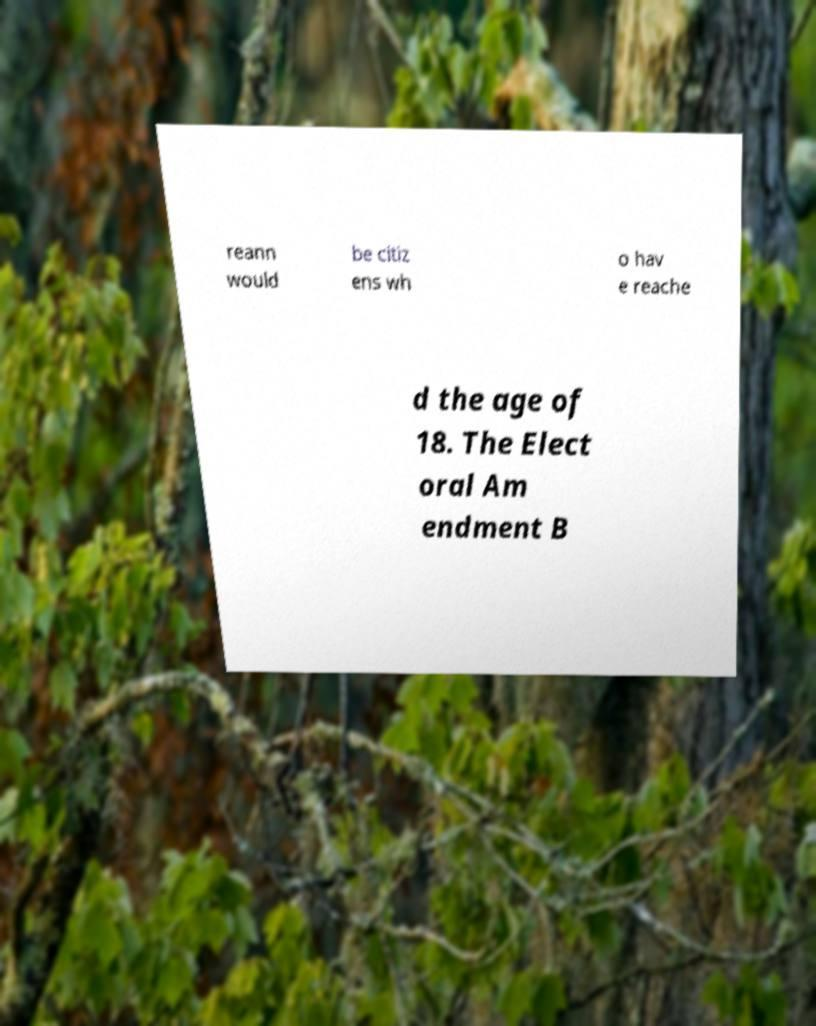Could you assist in decoding the text presented in this image and type it out clearly? reann would be citiz ens wh o hav e reache d the age of 18. The Elect oral Am endment B 